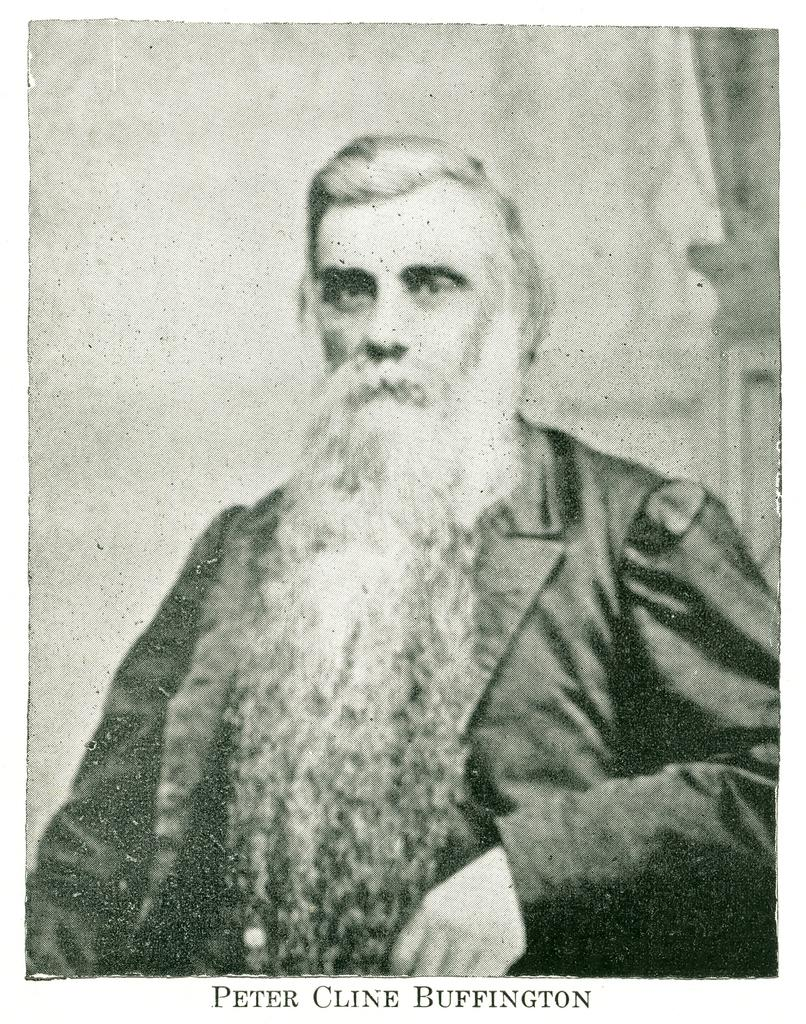Who is the main subject in the image? There is a man in the middle of the image. What is located at the bottom of the image? There is text at the bottom of the image. What color scheme is used in the image? The image is black and white. What type of lamp is used to sort items in the image? There is no lamp or sorting activity present in the image. 